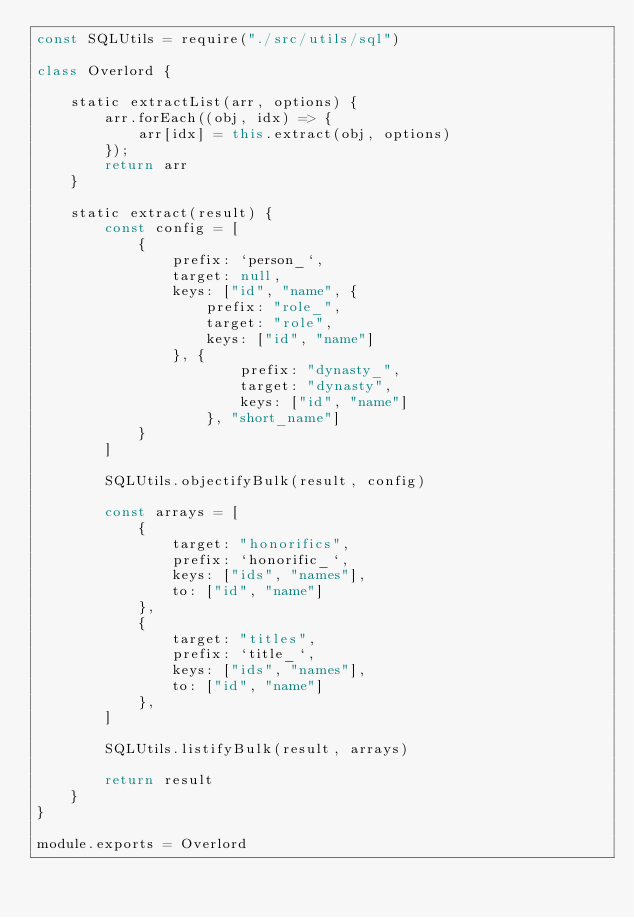Convert code to text. <code><loc_0><loc_0><loc_500><loc_500><_JavaScript_>const SQLUtils = require("./src/utils/sql")

class Overlord {

    static extractList(arr, options) {
        arr.forEach((obj, idx) => {
            arr[idx] = this.extract(obj, options)
        });
        return arr
    }

    static extract(result) {
        const config = [
            {
                prefix: `person_`,
                target: null,
                keys: ["id", "name", {
                    prefix: "role_",
                    target: "role",
                    keys: ["id", "name"]
                }, {
                        prefix: "dynasty_",
                        target: "dynasty",
                        keys: ["id", "name"]
                    }, "short_name"]
            }
        ]

        SQLUtils.objectifyBulk(result, config)

        const arrays = [
            {
                target: "honorifics",
                prefix: `honorific_`,
                keys: ["ids", "names"],
                to: ["id", "name"]
            },
            {
                target: "titles",
                prefix: `title_`,
                keys: ["ids", "names"],
                to: ["id", "name"]
            },
        ]

        SQLUtils.listifyBulk(result, arrays)

        return result
    }
}

module.exports = Overlord</code> 